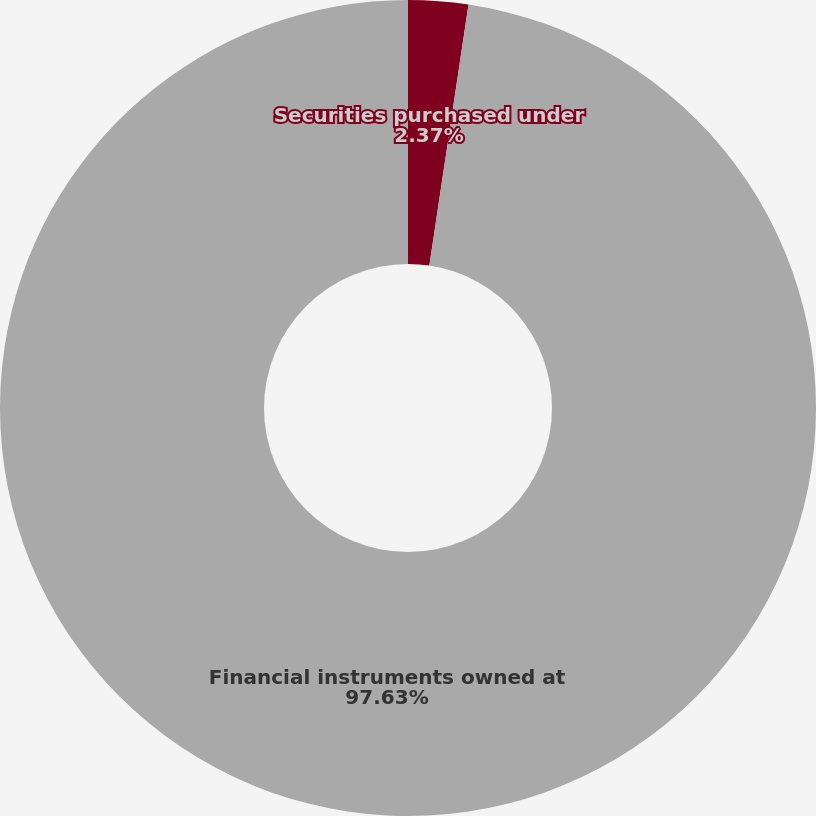Convert chart to OTSL. <chart><loc_0><loc_0><loc_500><loc_500><pie_chart><fcel>Securities purchased under<fcel>Financial instruments owned at<nl><fcel>2.37%<fcel>97.63%<nl></chart> 